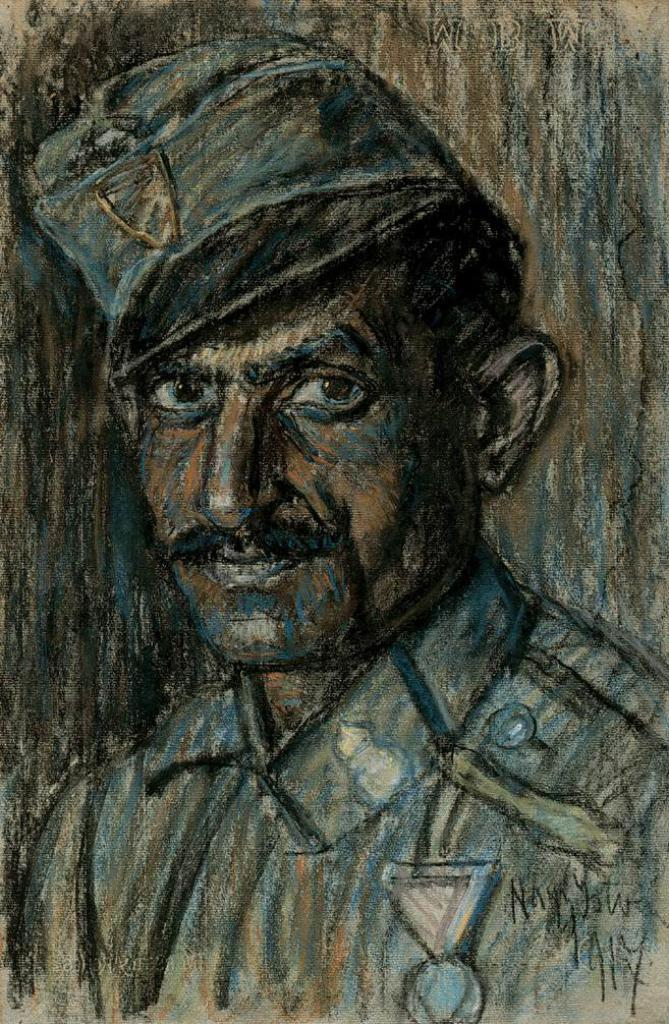What type of artwork is depicted in the image? The image is a painting. Can you describe the main subject of the painting? There is a person in the center of the painting. How many ants can be seen crawling on the person in the painting? There are no ants present in the painting; the main subject is a person. What type of cub is visible in the painting? There is no cub present in the painting; the main subject is a person. 